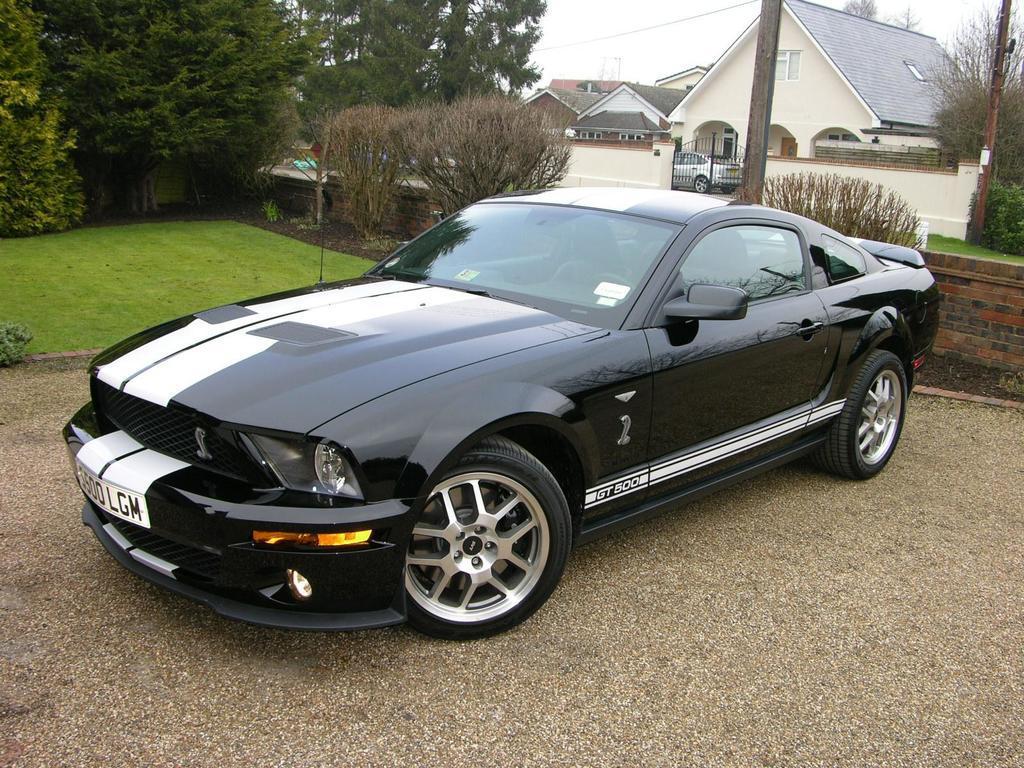In one or two sentences, can you explain what this image depicts? In the foreground of this image, there is a car on the ground. In the background, there are trees, grassland, wall, a pole, few buildings and the sky. 